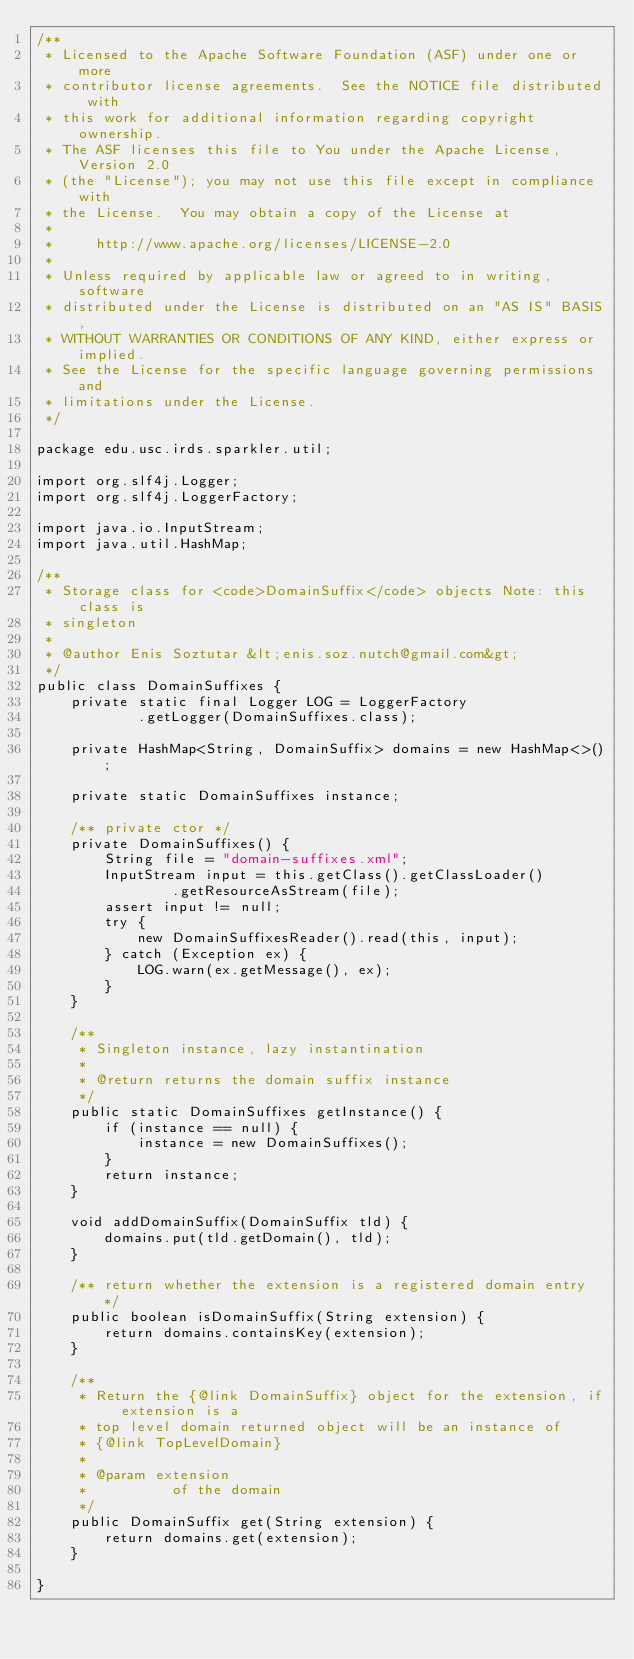Convert code to text. <code><loc_0><loc_0><loc_500><loc_500><_Java_>/**
 * Licensed to the Apache Software Foundation (ASF) under one or more
 * contributor license agreements.  See the NOTICE file distributed with
 * this work for additional information regarding copyright ownership.
 * The ASF licenses this file to You under the Apache License, Version 2.0
 * (the "License"); you may not use this file except in compliance with
 * the License.  You may obtain a copy of the License at
 *
 *     http://www.apache.org/licenses/LICENSE-2.0
 *
 * Unless required by applicable law or agreed to in writing, software
 * distributed under the License is distributed on an "AS IS" BASIS,
 * WITHOUT WARRANTIES OR CONDITIONS OF ANY KIND, either express or implied.
 * See the License for the specific language governing permissions and
 * limitations under the License.
 */

package edu.usc.irds.sparkler.util;

import org.slf4j.Logger;
import org.slf4j.LoggerFactory;

import java.io.InputStream;
import java.util.HashMap;

/**
 * Storage class for <code>DomainSuffix</code> objects Note: this class is
 * singleton
 *
 * @author Enis Soztutar &lt;enis.soz.nutch@gmail.com&gt;
 */
public class DomainSuffixes {
    private static final Logger LOG = LoggerFactory
            .getLogger(DomainSuffixes.class);

    private HashMap<String, DomainSuffix> domains = new HashMap<>();

    private static DomainSuffixes instance;

    /** private ctor */
    private DomainSuffixes() {
        String file = "domain-suffixes.xml";
        InputStream input = this.getClass().getClassLoader()
                .getResourceAsStream(file);
        assert input != null;
        try {
            new DomainSuffixesReader().read(this, input);
        } catch (Exception ex) {
            LOG.warn(ex.getMessage(), ex);
        }
    }

    /**
     * Singleton instance, lazy instantination
     *
     * @return returns the domain suffix instance
     */
    public static DomainSuffixes getInstance() {
        if (instance == null) {
            instance = new DomainSuffixes();
        }
        return instance;
    }

    void addDomainSuffix(DomainSuffix tld) {
        domains.put(tld.getDomain(), tld);
    }

    /** return whether the extension is a registered domain entry */
    public boolean isDomainSuffix(String extension) {
        return domains.containsKey(extension);
    }

    /**
     * Return the {@link DomainSuffix} object for the extension, if extension is a
     * top level domain returned object will be an instance of
     * {@link TopLevelDomain}
     *
     * @param extension
     *          of the domain
     */
    public DomainSuffix get(String extension) {
        return domains.get(extension);
    }

}</code> 